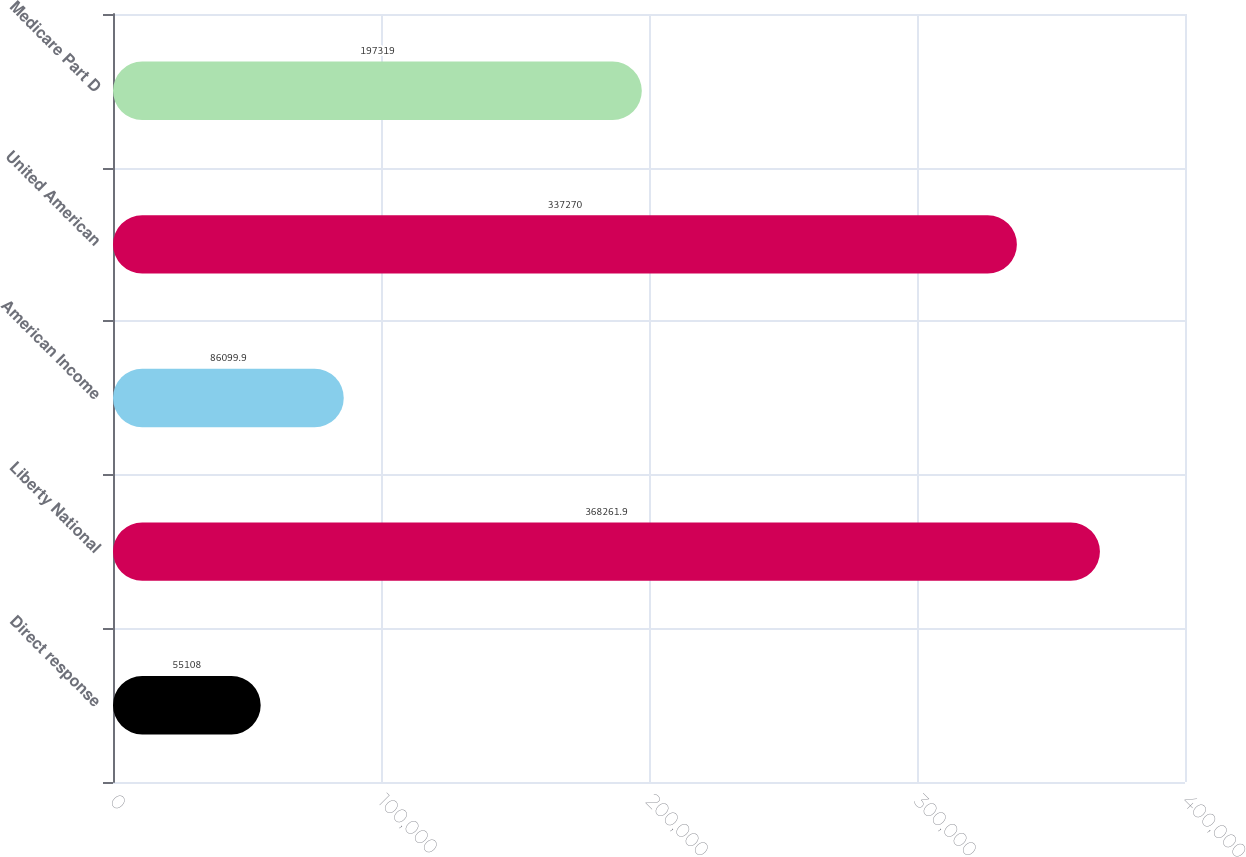Convert chart. <chart><loc_0><loc_0><loc_500><loc_500><bar_chart><fcel>Direct response<fcel>Liberty National<fcel>American Income<fcel>United American<fcel>Medicare Part D<nl><fcel>55108<fcel>368262<fcel>86099.9<fcel>337270<fcel>197319<nl></chart> 